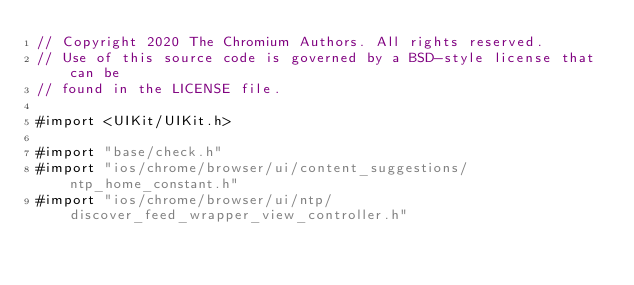<code> <loc_0><loc_0><loc_500><loc_500><_ObjectiveC_>// Copyright 2020 The Chromium Authors. All rights reserved.
// Use of this source code is governed by a BSD-style license that can be
// found in the LICENSE file.

#import <UIKit/UIKit.h>

#import "base/check.h"
#import "ios/chrome/browser/ui/content_suggestions/ntp_home_constant.h"
#import "ios/chrome/browser/ui/ntp/discover_feed_wrapper_view_controller.h"</code> 